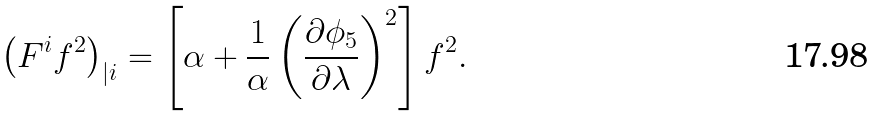<formula> <loc_0><loc_0><loc_500><loc_500>\left ( F ^ { i } f ^ { 2 } \right ) _ { | i } = \left [ \alpha + \frac { 1 } { \alpha } \left ( \frac { \partial \phi _ { 5 } } { \partial \lambda } \right ) ^ { 2 } \right ] f ^ { 2 } .</formula> 